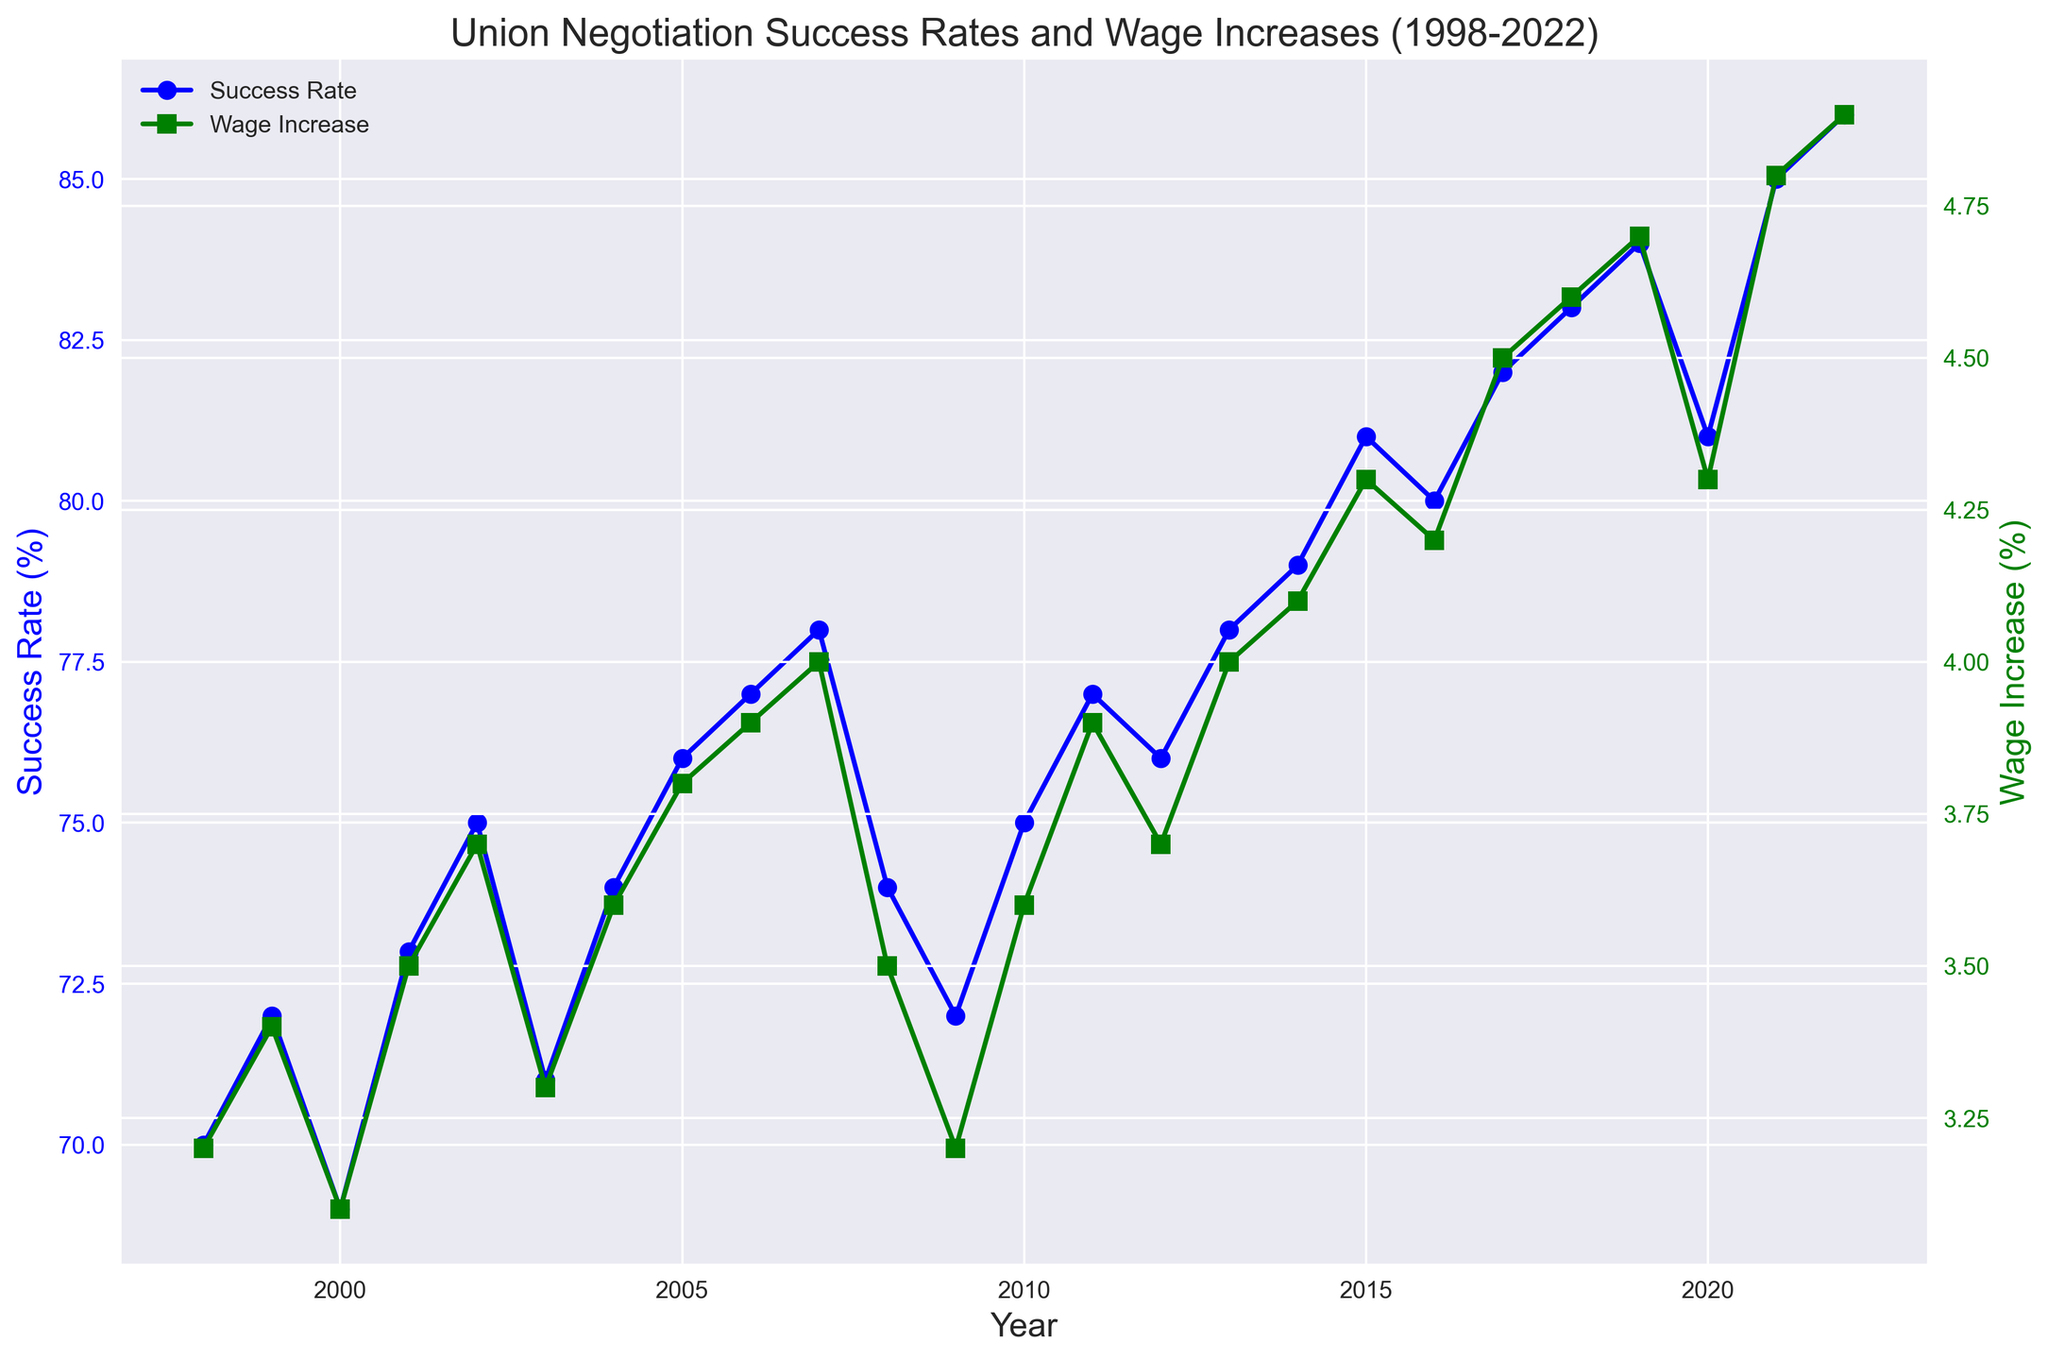What is the trend of the Success Rate over the period 1998 to 2022? From 1998 to 2022, we observe an overall increasing trend in the Success Rate. Initially starting at 70% in 1998, it gradually rises, with some fluctuations, to reach 86% in 2022.
Answer: Increasing How does the trend of Wage Increase compare to the trend of Success Rate from 1998 to 2022? Both the Success Rate and Wage Increase exhibit an overall increasing trend. While the Success Rate starts at 70% and ends at 86%, the Wage Increase starts at 3.2% and ends at 4.9%. Despite small fluctuations, both metrics show a positive upward trend over the 25-year span.
Answer: Both show an increasing trend In which year(s) did both the Success Rate and Wage Increase experience a decline? In the year 2009, both the Success Rate and Wage Increase experienced a decline. The Success Rate dropped from 74% in 2008 to 72% in 2009, and the Wage Increase fell from 3.5% to 3.2% during the same period.
Answer: 2009 What is the average Success Rate for the years 2018 to 2022? The Success Rates from 2018 to 2022 are 83%, 84%, 81%, 85%, and 86%. Summing these values gives 419. Dividing this sum by the number of values (5) provides the average: 419 / 5 = 83.8.
Answer: 83.8% Which year had the highest Wage Increase and what was its percentage? The year 2022 had the highest Wage Increase, with a percentage of 4.9%.
Answer: 2022, 4.9% Which year shows the largest year-over-year increase in Success Rate? Comparing the year-over-year increases in Success Rates, the largest increase is observed from 2014 to 2015. The Success Rate increased from 79% in 2014 to 81% in 2015, a difference of 2%.
Answer: 2015 What is the difference between the highest and lowest Wage Increase values over the 25-year period? The highest Wage Increase is 4.9% in 2022, and the lowest is 3.1% in 2000. The difference between these two values is 4.9% - 3.1% = 1.8%.
Answer: 1.8% During which time period did the Wage Increase remain relatively stable despite fluctuations in the Success Rate? From 2008 to 2012, the Wage Increase remains relatively stable, varying between 3.5% and 3.7%, despite fluctuations in the Success Rate, which ranges from 72% to 77% during the same period.
Answer: 2008-2012 Over the 25-year period, how many years saw both the Success Rate and Wage Increase increasing compared to the previous year? We analyze the year-over-year changes for both Success Rate and Wage Increase. The years that show both metrics increasing compared to the previous year are 1999, 2001, 2002, 2004, 2005, 2006, 2007, 2010, 2011, 2013, 2014, 2015, 2017, 2018, 2019, 2021, and 2022, making a total of 17 years.
Answer: 17 years 